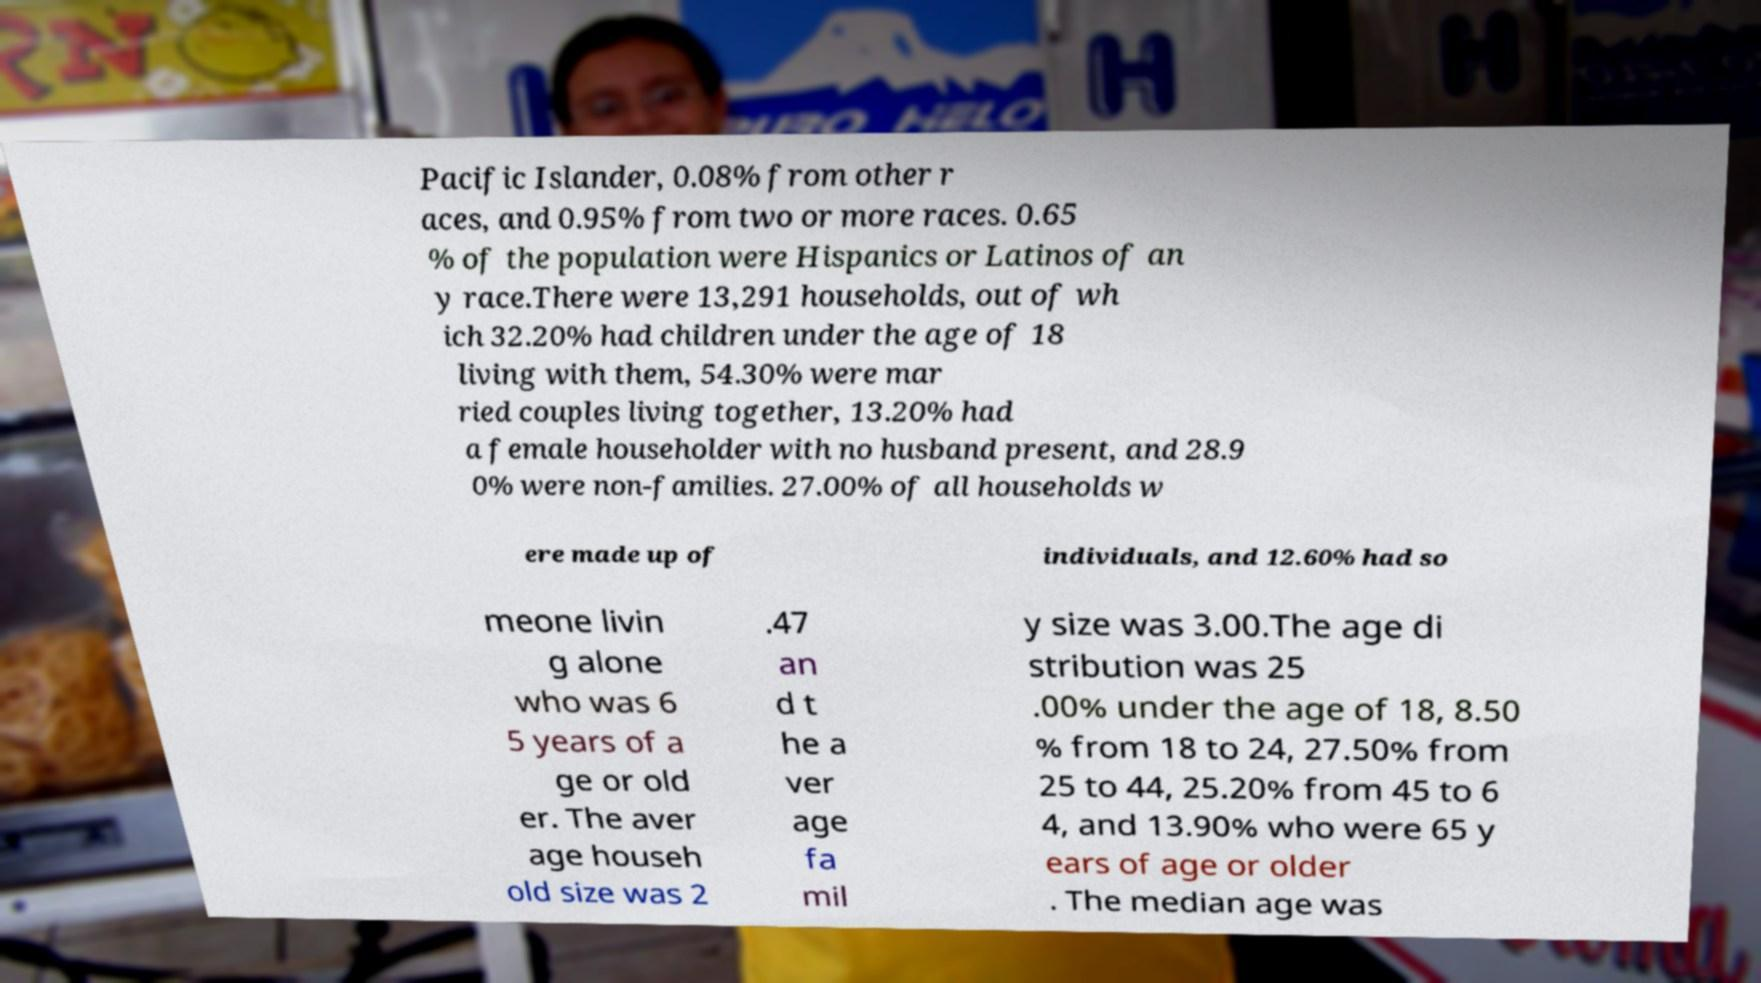Please identify and transcribe the text found in this image. Pacific Islander, 0.08% from other r aces, and 0.95% from two or more races. 0.65 % of the population were Hispanics or Latinos of an y race.There were 13,291 households, out of wh ich 32.20% had children under the age of 18 living with them, 54.30% were mar ried couples living together, 13.20% had a female householder with no husband present, and 28.9 0% were non-families. 27.00% of all households w ere made up of individuals, and 12.60% had so meone livin g alone who was 6 5 years of a ge or old er. The aver age househ old size was 2 .47 an d t he a ver age fa mil y size was 3.00.The age di stribution was 25 .00% under the age of 18, 8.50 % from 18 to 24, 27.50% from 25 to 44, 25.20% from 45 to 6 4, and 13.90% who were 65 y ears of age or older . The median age was 